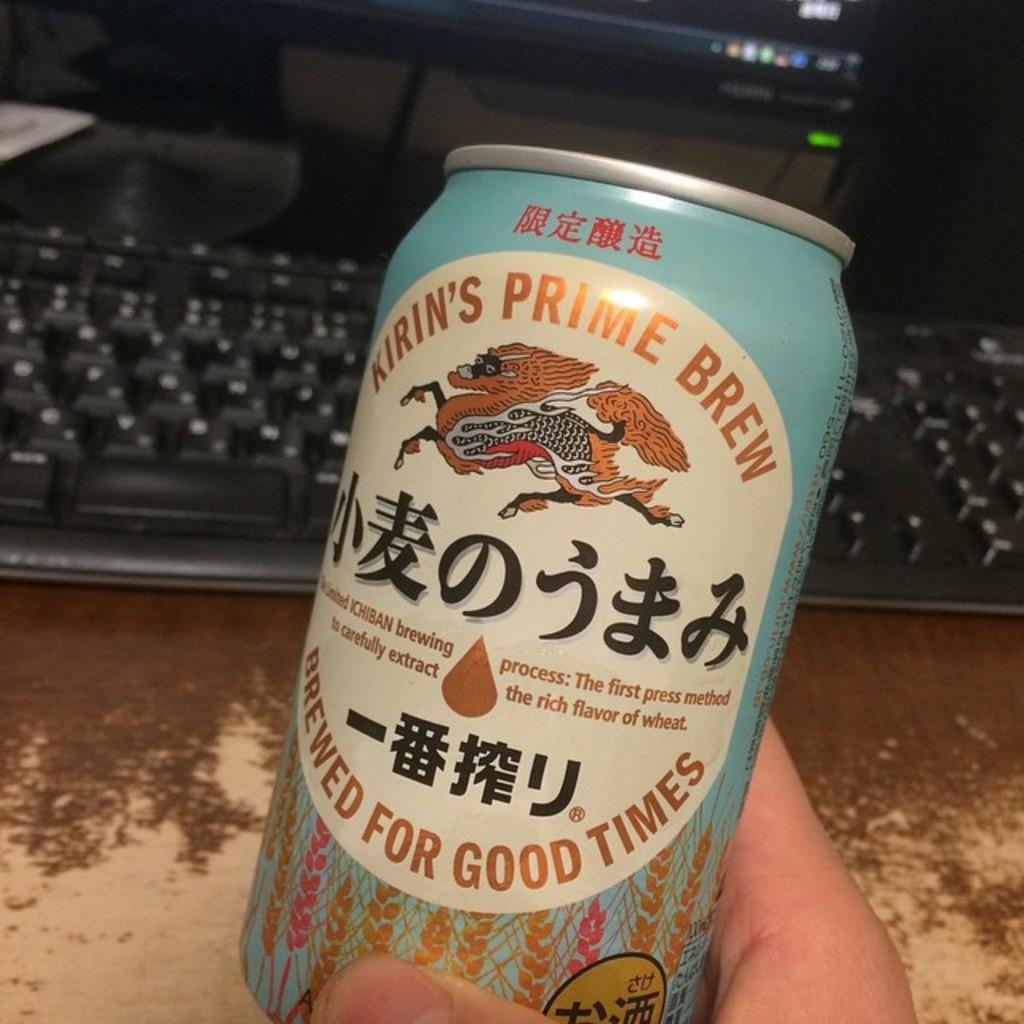For what kind of times is this drink brewed?
Your answer should be very brief. Good times. What is the name of this brew?
Your response must be concise. Kirin's prime brew. 